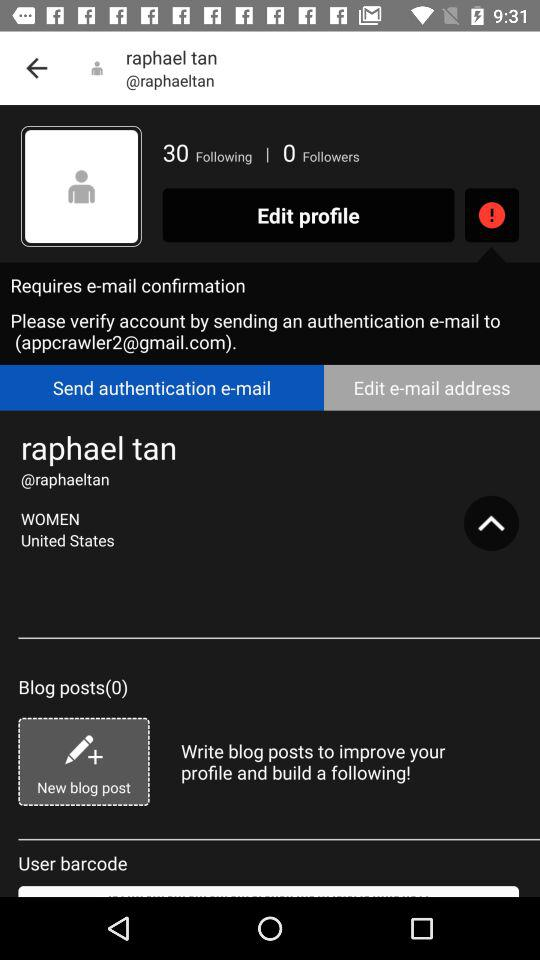How many blog posts does the user have?
Answer the question using a single word or phrase. 0 